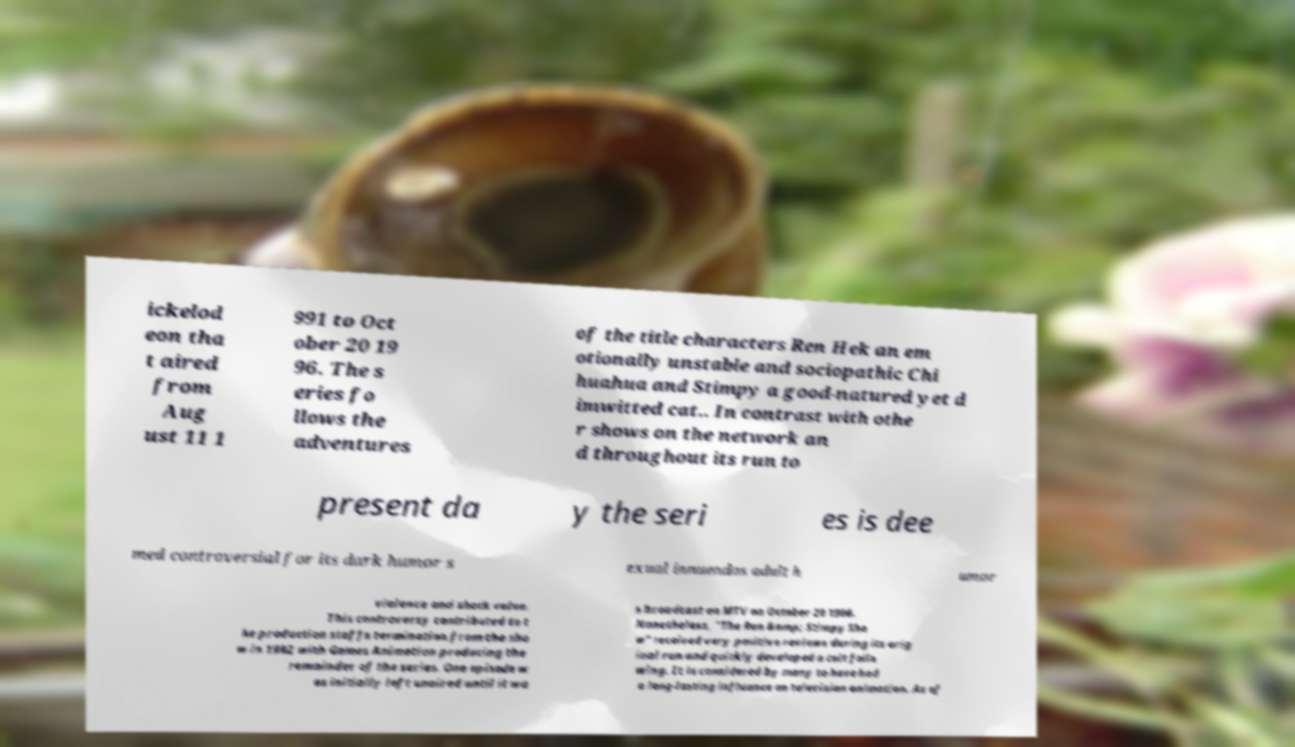For documentation purposes, I need the text within this image transcribed. Could you provide that? ickelod eon tha t aired from Aug ust 11 1 991 to Oct ober 20 19 96. The s eries fo llows the adventures of the title characters Ren Hek an em otionally unstable and sociopathic Chi huahua and Stimpy a good-natured yet d imwitted cat.. In contrast with othe r shows on the network an d throughout its run to present da y the seri es is dee med controversial for its dark humor s exual innuendos adult h umor violence and shock value. This controversy contributed to t he production staffs termination from the sho w in 1992 with Games Animation producing the remainder of the series. One episode w as initially left unaired until it wa s broadcast on MTV on October 20 1996. Nonetheless, "The Ren &amp; Stimpy Sho w" received very positive reviews during its orig inal run and quickly developed a cult follo wing. It is considered by many to have had a long-lasting influence on television animation. As of 